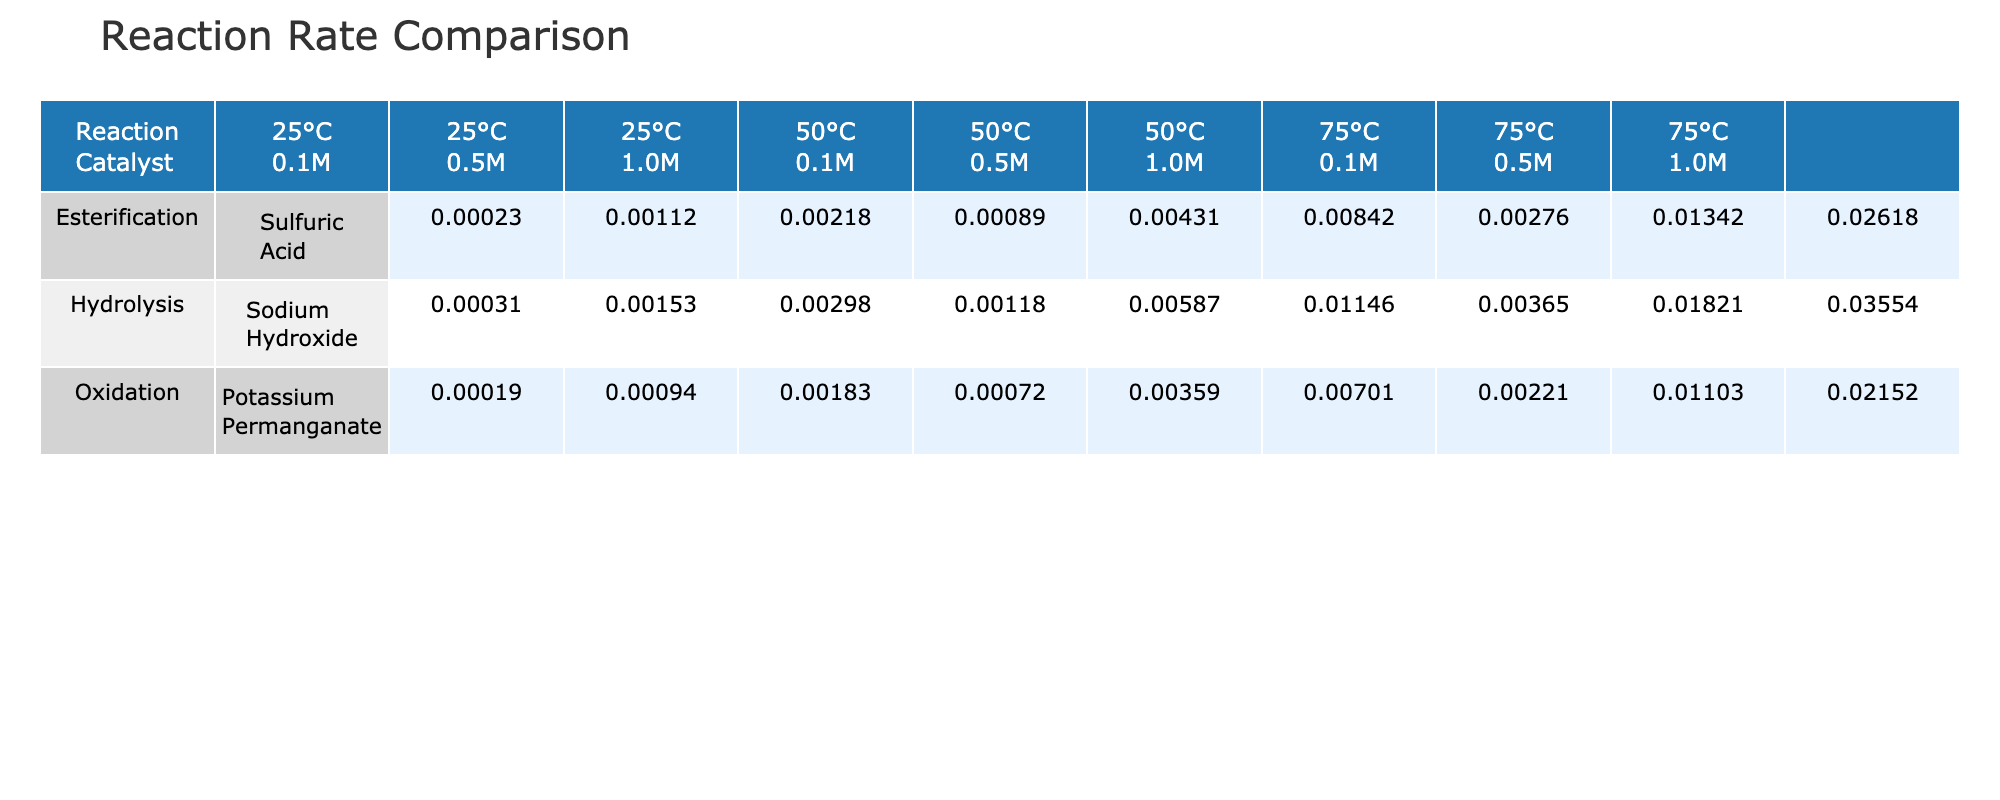What is the reaction rate of Esterification with a 0.5 M concentration at 50°C? By locating the row for Esterification and finding the column corresponding to 50°C and 0.5 M concentration, the value is identified as 0.00431.
Answer: 0.00431 Which reaction had the highest rate at 75°C? Checking the row for each reaction type at 75°C, Esterification at 1.0 M concentration shows the highest value of 0.02618, compared to Hydrolysis (0.03554) and Oxidation (0.02152).
Answer: Hydrolysis What is the average reaction rate for Hydrolysis across all temperatures and concentrations? Summing the reaction rates (0.00031 + 0.00153 + 0.00298 + 0.00118 + 0.00587 + 0.01146 + 0.00365 + 0.01821 + 0.03554 = 0.08066) gives 0.08066, and dividing by 9 (the number of data points) results in an average of approximately 0.00896.
Answer: 0.00896 Is the reaction rate for Oxidation at 50°C greater than that for Esterification at the same temperature? Comparing the reaction rates for Oxidation (values: 0.00072, 0.00359, 0.00701) and Esterification (values: 0.00089, 0.00431, 0.00842), we see that for all concentrations, Oxidation rates are lower. Therefore, the answer is no.
Answer: No Different reactions were performed with the same catalyst. How many reaction combinations are there with Sodium Hydroxide at 75°C? Looking at the Hydrolysis row with Sodium Hydroxide at 75°C, there are three trials (0.1 M, 0.5 M, 1.0 M). Thus, the total number of combinations for this catalyst at 75°C is three.
Answer: 3 